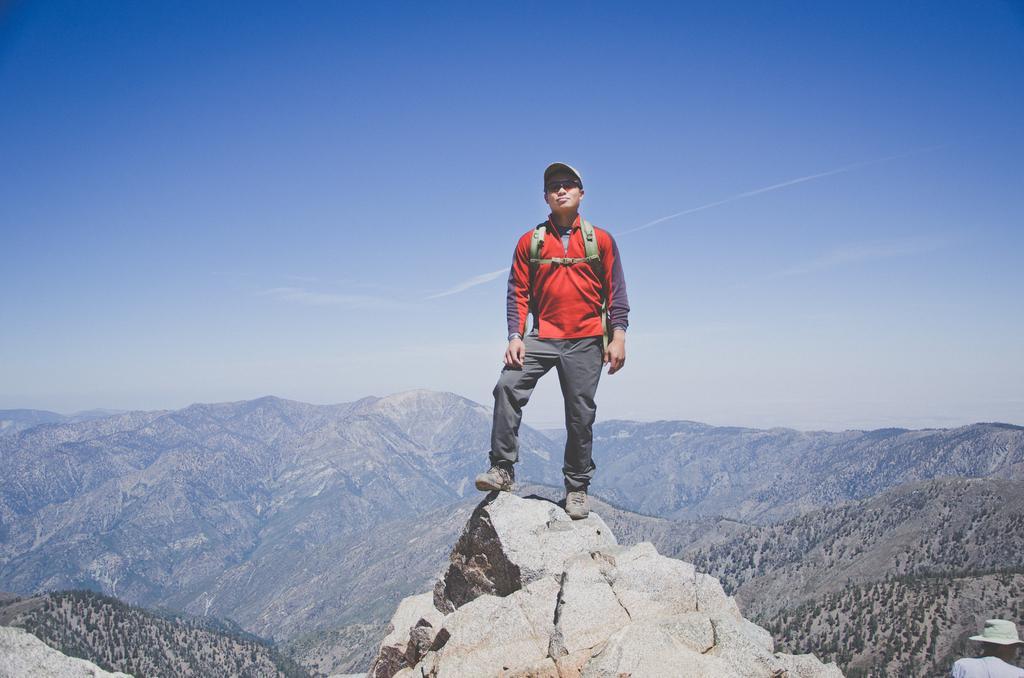How would you summarize this image in a sentence or two? In this image I can see a person standing on the rock. In the background, I can see the trees, hills and clouds in the sky. 